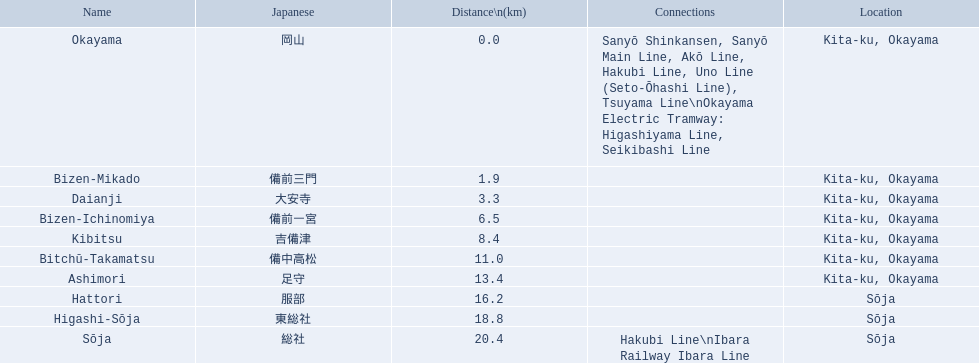Who are the components of the kibi line? Okayama, Bizen-Mikado, Daianji, Bizen-Ichinomiya, Kibitsu, Bitchū-Takamatsu, Ashimori, Hattori, Higashi-Sōja, Sōja. Which of these are further than 1 km? Bizen-Mikado, Daianji, Bizen-Ichinomiya, Kibitsu, Bitchū-Takamatsu, Ashimori, Hattori, Higashi-Sōja, Sōja. Which are closer than 2 km? Okayama, Bizen-Mikado. And which are situated between 1 km and 2 km? Bizen-Mikado. 